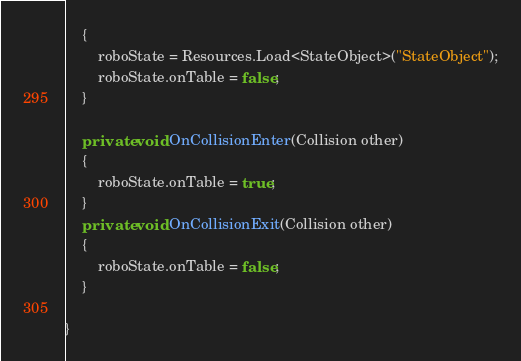<code> <loc_0><loc_0><loc_500><loc_500><_C#_>    {
        roboState = Resources.Load<StateObject>("StateObject");
        roboState.onTable = false; 
    }

    private void OnCollisionEnter(Collision other) 
    {
        roboState.onTable = true; 
    }
    private void OnCollisionExit(Collision other) 
    {
        roboState.onTable = false;     
    }

}
</code> 